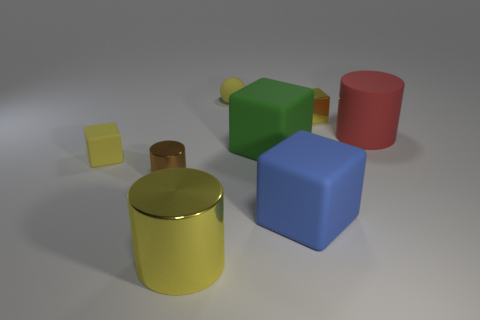There is a cylinder that is the same color as the metallic cube; what is it made of?
Offer a terse response. Metal. There is a metallic object that is to the right of the green matte block; is its color the same as the rubber sphere?
Offer a terse response. Yes. What is the shape of the metallic object behind the small matte object that is on the left side of the tiny yellow sphere?
Offer a very short reply. Cube. Are there fewer metal blocks that are in front of the red object than large cylinders that are in front of the tiny matte block?
Your answer should be compact. Yes. What size is the yellow metal thing that is the same shape as the big blue rubber thing?
Keep it short and to the point. Small. How many objects are big things that are on the left side of the large red rubber thing or things that are behind the yellow shiny block?
Keep it short and to the point. 4. Is the size of the blue thing the same as the brown metallic thing?
Offer a terse response. No. Is the number of yellow shiny cylinders greater than the number of green shiny balls?
Provide a short and direct response. Yes. How many other objects are the same color as the tiny rubber ball?
Provide a succinct answer. 3. What number of objects are big green objects or tiny brown metal things?
Give a very brief answer. 2. 